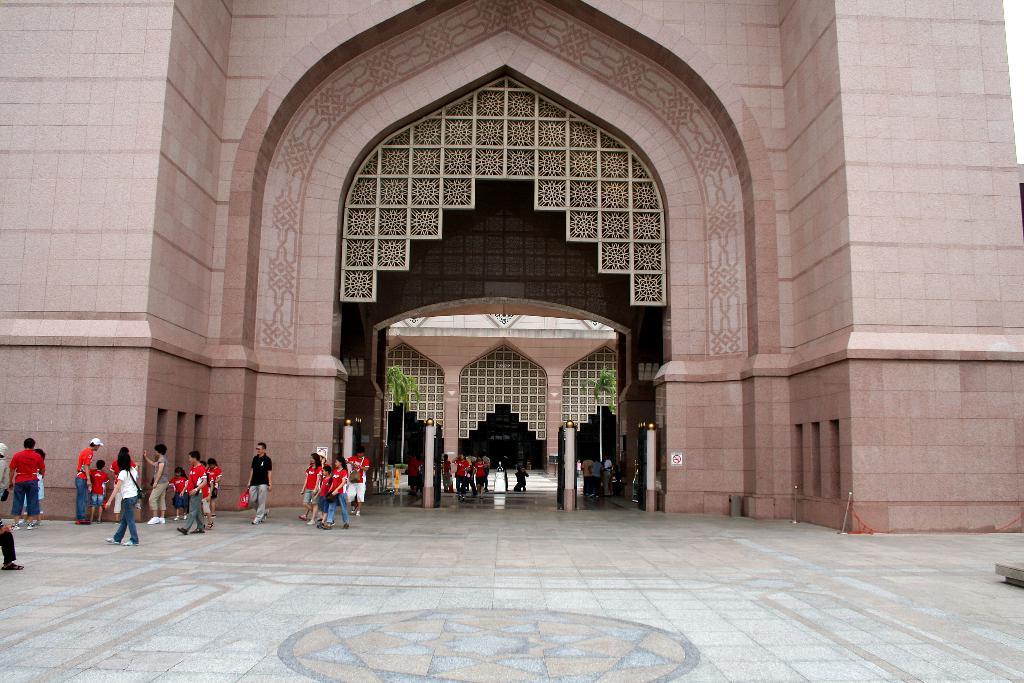Can you describe this image briefly? On the left i can see many peoples were standing and walking near to the wall. In the center i can see building and door. In the top right corner there is a sky. At the bottom i can see some circle structure on the floor. 